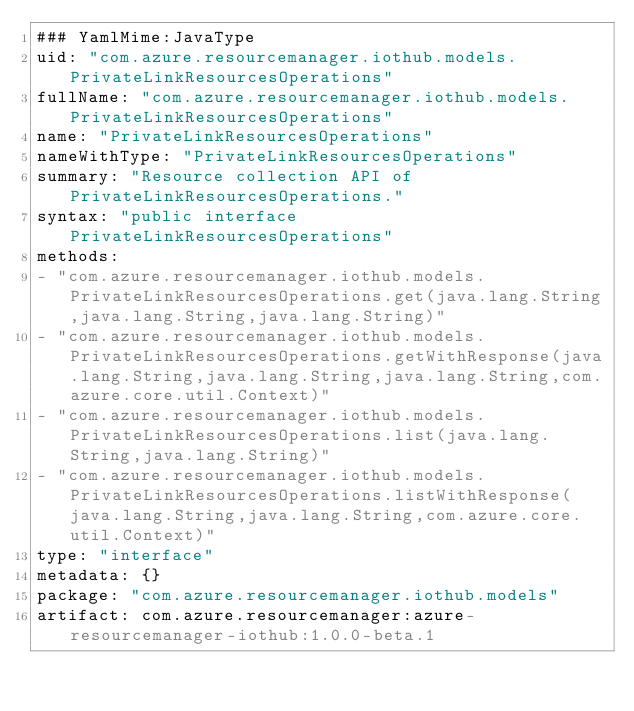<code> <loc_0><loc_0><loc_500><loc_500><_YAML_>### YamlMime:JavaType
uid: "com.azure.resourcemanager.iothub.models.PrivateLinkResourcesOperations"
fullName: "com.azure.resourcemanager.iothub.models.PrivateLinkResourcesOperations"
name: "PrivateLinkResourcesOperations"
nameWithType: "PrivateLinkResourcesOperations"
summary: "Resource collection API of PrivateLinkResourcesOperations."
syntax: "public interface PrivateLinkResourcesOperations"
methods:
- "com.azure.resourcemanager.iothub.models.PrivateLinkResourcesOperations.get(java.lang.String,java.lang.String,java.lang.String)"
- "com.azure.resourcemanager.iothub.models.PrivateLinkResourcesOperations.getWithResponse(java.lang.String,java.lang.String,java.lang.String,com.azure.core.util.Context)"
- "com.azure.resourcemanager.iothub.models.PrivateLinkResourcesOperations.list(java.lang.String,java.lang.String)"
- "com.azure.resourcemanager.iothub.models.PrivateLinkResourcesOperations.listWithResponse(java.lang.String,java.lang.String,com.azure.core.util.Context)"
type: "interface"
metadata: {}
package: "com.azure.resourcemanager.iothub.models"
artifact: com.azure.resourcemanager:azure-resourcemanager-iothub:1.0.0-beta.1
</code> 